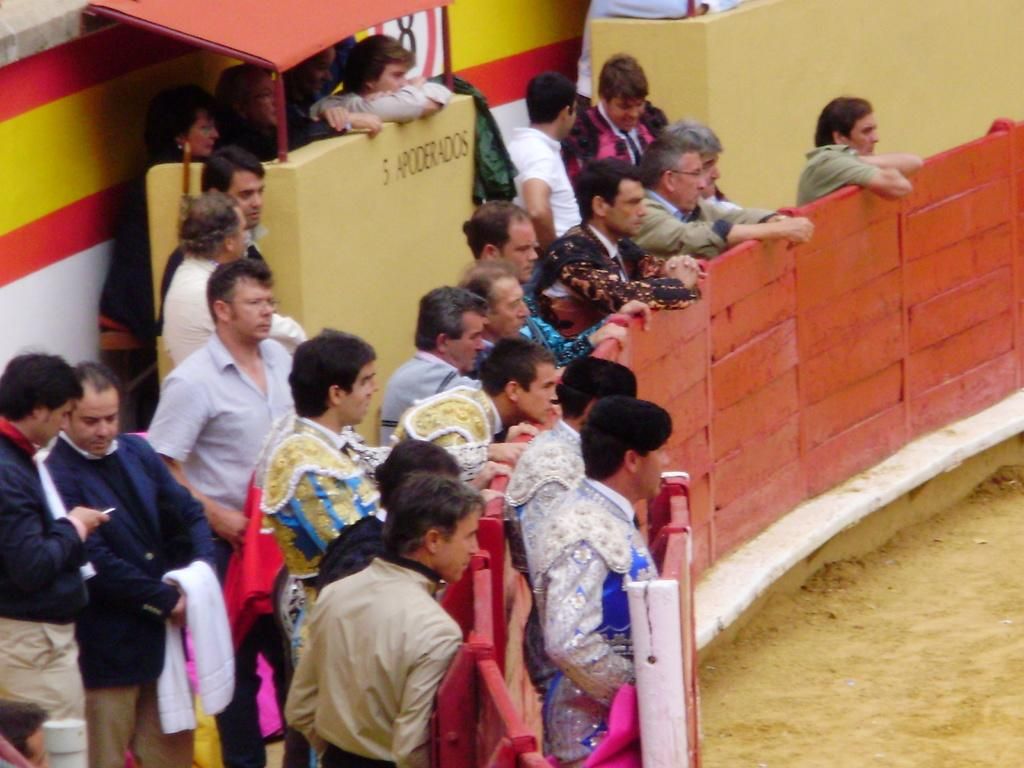How many people are in the image? There is a group of people in the image, but the exact number is not specified. What are the people wearing? The people are wearing different color dresses. What are some people holding in the image? Some people are holding something, but the specific objects are not mentioned. What type of fencing can be seen in the image? There is orange color fencing in the image. What type of terrain is visible in the image? There is sand visible in the image. What type of hospital can be seen in the image? There is no hospital present in the image. How can the people in the image join together to form a single entity? The people in the image are not depicted as joining together to form a single entity. 